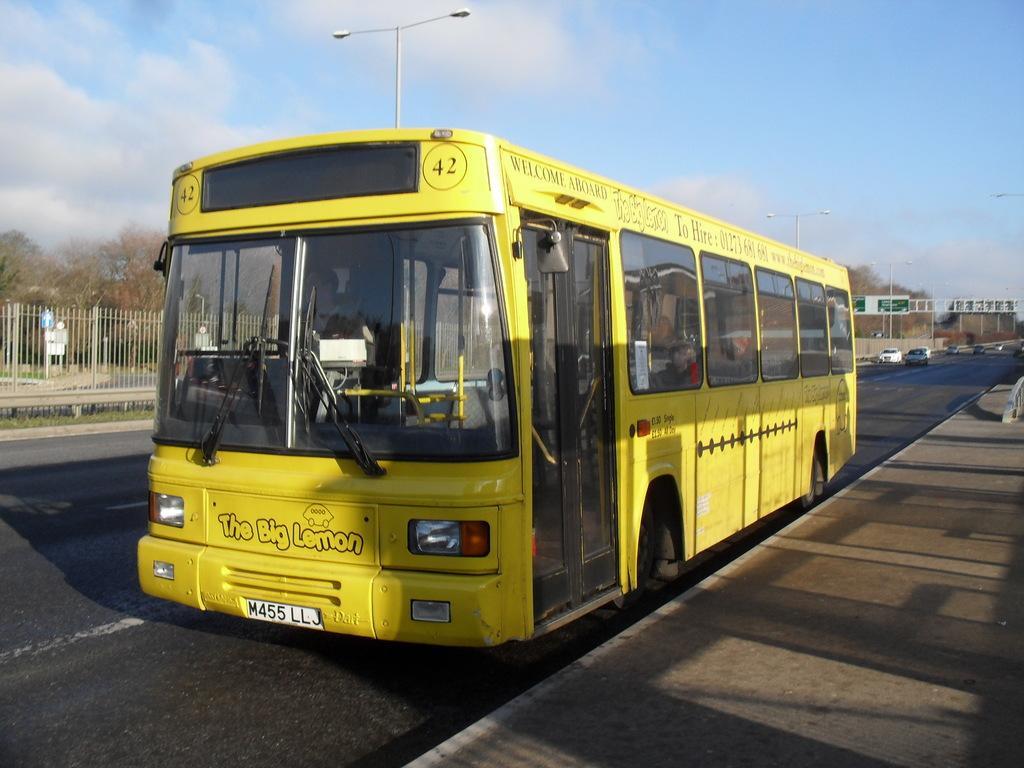Could you give a brief overview of what you see in this image? In the foreground the picture there is a bus, in the bus there are people. On the right it is footpath. In the center of the background there are trees, boards cars and railing. on the right there are cars. On left there are trees, railing and grass. In the center of the picture there is a street light. 